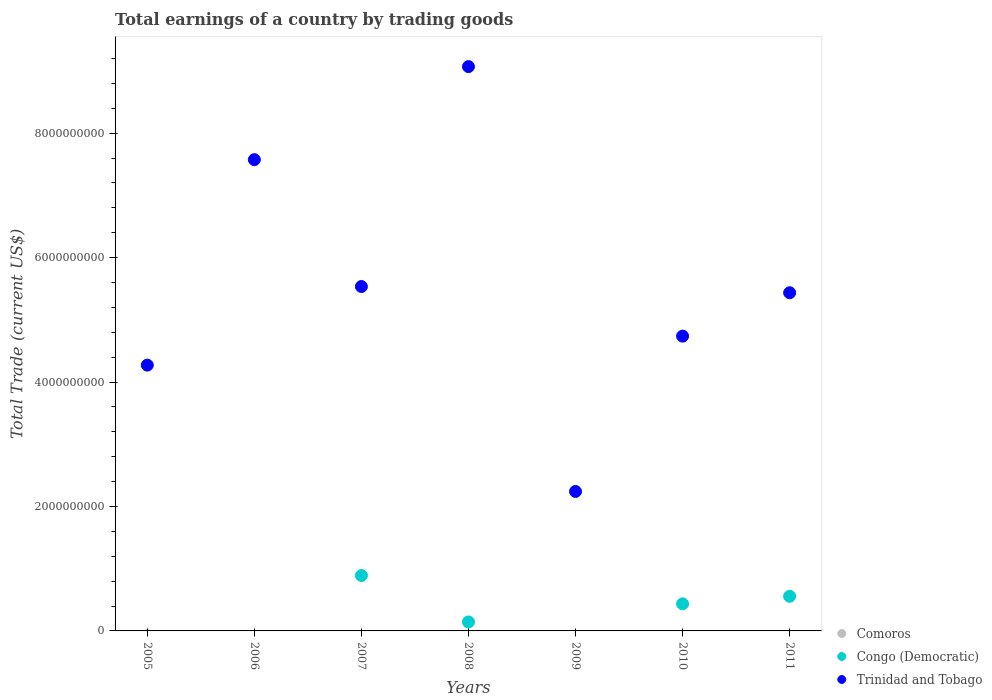Is the number of dotlines equal to the number of legend labels?
Your response must be concise. No. What is the total earnings in Comoros in 2011?
Provide a short and direct response. 0. Across all years, what is the maximum total earnings in Congo (Democratic)?
Offer a very short reply. 8.91e+08. Across all years, what is the minimum total earnings in Congo (Democratic)?
Provide a succinct answer. 0. In which year was the total earnings in Congo (Democratic) maximum?
Your answer should be compact. 2007. What is the total total earnings in Congo (Democratic) in the graph?
Your response must be concise. 2.03e+09. What is the difference between the total earnings in Trinidad and Tobago in 2005 and that in 2008?
Provide a short and direct response. -4.80e+09. What is the difference between the total earnings in Congo (Democratic) in 2006 and the total earnings in Trinidad and Tobago in 2010?
Keep it short and to the point. -4.74e+09. What is the average total earnings in Comoros per year?
Provide a succinct answer. 0. In the year 2008, what is the difference between the total earnings in Congo (Democratic) and total earnings in Trinidad and Tobago?
Your answer should be compact. -8.93e+09. In how many years, is the total earnings in Congo (Democratic) greater than 8400000000 US$?
Your answer should be compact. 0. What is the ratio of the total earnings in Congo (Democratic) in 2007 to that in 2008?
Provide a succinct answer. 6.19. Is the total earnings in Trinidad and Tobago in 2005 less than that in 2008?
Your answer should be compact. Yes. What is the difference between the highest and the second highest total earnings in Trinidad and Tobago?
Provide a succinct answer. 1.50e+09. What is the difference between the highest and the lowest total earnings in Congo (Democratic)?
Your answer should be compact. 8.91e+08. In how many years, is the total earnings in Comoros greater than the average total earnings in Comoros taken over all years?
Provide a succinct answer. 0. Is the sum of the total earnings in Trinidad and Tobago in 2009 and 2011 greater than the maximum total earnings in Comoros across all years?
Make the answer very short. Yes. Is it the case that in every year, the sum of the total earnings in Trinidad and Tobago and total earnings in Congo (Democratic)  is greater than the total earnings in Comoros?
Offer a very short reply. Yes. How many dotlines are there?
Offer a very short reply. 2. Does the graph contain any zero values?
Keep it short and to the point. Yes. Does the graph contain grids?
Provide a succinct answer. No. How are the legend labels stacked?
Offer a very short reply. Vertical. What is the title of the graph?
Offer a terse response. Total earnings of a country by trading goods. What is the label or title of the Y-axis?
Keep it short and to the point. Total Trade (current US$). What is the Total Trade (current US$) in Trinidad and Tobago in 2005?
Provide a succinct answer. 4.27e+09. What is the Total Trade (current US$) of Trinidad and Tobago in 2006?
Offer a terse response. 7.57e+09. What is the Total Trade (current US$) in Congo (Democratic) in 2007?
Offer a very short reply. 8.91e+08. What is the Total Trade (current US$) of Trinidad and Tobago in 2007?
Provide a short and direct response. 5.54e+09. What is the Total Trade (current US$) in Comoros in 2008?
Your answer should be compact. 0. What is the Total Trade (current US$) in Congo (Democratic) in 2008?
Provide a short and direct response. 1.44e+08. What is the Total Trade (current US$) in Trinidad and Tobago in 2008?
Provide a short and direct response. 9.07e+09. What is the Total Trade (current US$) in Comoros in 2009?
Your response must be concise. 0. What is the Total Trade (current US$) in Congo (Democratic) in 2009?
Your response must be concise. 0. What is the Total Trade (current US$) in Trinidad and Tobago in 2009?
Make the answer very short. 2.24e+09. What is the Total Trade (current US$) in Comoros in 2010?
Give a very brief answer. 0. What is the Total Trade (current US$) in Congo (Democratic) in 2010?
Keep it short and to the point. 4.35e+08. What is the Total Trade (current US$) of Trinidad and Tobago in 2010?
Your answer should be compact. 4.74e+09. What is the Total Trade (current US$) of Congo (Democratic) in 2011?
Make the answer very short. 5.56e+08. What is the Total Trade (current US$) of Trinidad and Tobago in 2011?
Make the answer very short. 5.43e+09. Across all years, what is the maximum Total Trade (current US$) of Congo (Democratic)?
Provide a succinct answer. 8.91e+08. Across all years, what is the maximum Total Trade (current US$) in Trinidad and Tobago?
Offer a very short reply. 9.07e+09. Across all years, what is the minimum Total Trade (current US$) of Trinidad and Tobago?
Offer a terse response. 2.24e+09. What is the total Total Trade (current US$) in Congo (Democratic) in the graph?
Give a very brief answer. 2.03e+09. What is the total Total Trade (current US$) of Trinidad and Tobago in the graph?
Provide a short and direct response. 3.89e+1. What is the difference between the Total Trade (current US$) of Trinidad and Tobago in 2005 and that in 2006?
Give a very brief answer. -3.30e+09. What is the difference between the Total Trade (current US$) in Trinidad and Tobago in 2005 and that in 2007?
Offer a terse response. -1.26e+09. What is the difference between the Total Trade (current US$) in Trinidad and Tobago in 2005 and that in 2008?
Your answer should be very brief. -4.80e+09. What is the difference between the Total Trade (current US$) of Trinidad and Tobago in 2005 and that in 2009?
Make the answer very short. 2.03e+09. What is the difference between the Total Trade (current US$) in Trinidad and Tobago in 2005 and that in 2010?
Provide a succinct answer. -4.66e+08. What is the difference between the Total Trade (current US$) of Trinidad and Tobago in 2005 and that in 2011?
Offer a very short reply. -1.16e+09. What is the difference between the Total Trade (current US$) in Trinidad and Tobago in 2006 and that in 2007?
Make the answer very short. 2.04e+09. What is the difference between the Total Trade (current US$) of Trinidad and Tobago in 2006 and that in 2008?
Your response must be concise. -1.50e+09. What is the difference between the Total Trade (current US$) of Trinidad and Tobago in 2006 and that in 2009?
Your answer should be compact. 5.33e+09. What is the difference between the Total Trade (current US$) in Trinidad and Tobago in 2006 and that in 2010?
Provide a short and direct response. 2.84e+09. What is the difference between the Total Trade (current US$) in Trinidad and Tobago in 2006 and that in 2011?
Offer a terse response. 2.14e+09. What is the difference between the Total Trade (current US$) in Congo (Democratic) in 2007 and that in 2008?
Your response must be concise. 7.47e+08. What is the difference between the Total Trade (current US$) in Trinidad and Tobago in 2007 and that in 2008?
Offer a terse response. -3.53e+09. What is the difference between the Total Trade (current US$) in Trinidad and Tobago in 2007 and that in 2009?
Give a very brief answer. 3.29e+09. What is the difference between the Total Trade (current US$) in Congo (Democratic) in 2007 and that in 2010?
Ensure brevity in your answer.  4.55e+08. What is the difference between the Total Trade (current US$) in Trinidad and Tobago in 2007 and that in 2010?
Give a very brief answer. 7.97e+08. What is the difference between the Total Trade (current US$) in Congo (Democratic) in 2007 and that in 2011?
Ensure brevity in your answer.  3.34e+08. What is the difference between the Total Trade (current US$) of Trinidad and Tobago in 2007 and that in 2011?
Keep it short and to the point. 1.01e+08. What is the difference between the Total Trade (current US$) of Trinidad and Tobago in 2008 and that in 2009?
Offer a terse response. 6.83e+09. What is the difference between the Total Trade (current US$) in Congo (Democratic) in 2008 and that in 2010?
Ensure brevity in your answer.  -2.91e+08. What is the difference between the Total Trade (current US$) in Trinidad and Tobago in 2008 and that in 2010?
Provide a short and direct response. 4.33e+09. What is the difference between the Total Trade (current US$) of Congo (Democratic) in 2008 and that in 2011?
Give a very brief answer. -4.12e+08. What is the difference between the Total Trade (current US$) in Trinidad and Tobago in 2008 and that in 2011?
Provide a short and direct response. 3.63e+09. What is the difference between the Total Trade (current US$) in Trinidad and Tobago in 2009 and that in 2010?
Ensure brevity in your answer.  -2.50e+09. What is the difference between the Total Trade (current US$) of Trinidad and Tobago in 2009 and that in 2011?
Provide a succinct answer. -3.19e+09. What is the difference between the Total Trade (current US$) in Congo (Democratic) in 2010 and that in 2011?
Provide a succinct answer. -1.21e+08. What is the difference between the Total Trade (current US$) of Trinidad and Tobago in 2010 and that in 2011?
Ensure brevity in your answer.  -6.97e+08. What is the difference between the Total Trade (current US$) of Congo (Democratic) in 2007 and the Total Trade (current US$) of Trinidad and Tobago in 2008?
Offer a very short reply. -8.18e+09. What is the difference between the Total Trade (current US$) in Congo (Democratic) in 2007 and the Total Trade (current US$) in Trinidad and Tobago in 2009?
Give a very brief answer. -1.35e+09. What is the difference between the Total Trade (current US$) of Congo (Democratic) in 2007 and the Total Trade (current US$) of Trinidad and Tobago in 2010?
Ensure brevity in your answer.  -3.85e+09. What is the difference between the Total Trade (current US$) of Congo (Democratic) in 2007 and the Total Trade (current US$) of Trinidad and Tobago in 2011?
Provide a succinct answer. -4.54e+09. What is the difference between the Total Trade (current US$) in Congo (Democratic) in 2008 and the Total Trade (current US$) in Trinidad and Tobago in 2009?
Offer a very short reply. -2.10e+09. What is the difference between the Total Trade (current US$) in Congo (Democratic) in 2008 and the Total Trade (current US$) in Trinidad and Tobago in 2010?
Ensure brevity in your answer.  -4.59e+09. What is the difference between the Total Trade (current US$) in Congo (Democratic) in 2008 and the Total Trade (current US$) in Trinidad and Tobago in 2011?
Offer a terse response. -5.29e+09. What is the difference between the Total Trade (current US$) of Congo (Democratic) in 2010 and the Total Trade (current US$) of Trinidad and Tobago in 2011?
Make the answer very short. -5.00e+09. What is the average Total Trade (current US$) of Comoros per year?
Offer a very short reply. 0. What is the average Total Trade (current US$) in Congo (Democratic) per year?
Provide a succinct answer. 2.89e+08. What is the average Total Trade (current US$) of Trinidad and Tobago per year?
Provide a short and direct response. 5.55e+09. In the year 2007, what is the difference between the Total Trade (current US$) in Congo (Democratic) and Total Trade (current US$) in Trinidad and Tobago?
Keep it short and to the point. -4.64e+09. In the year 2008, what is the difference between the Total Trade (current US$) in Congo (Democratic) and Total Trade (current US$) in Trinidad and Tobago?
Your answer should be compact. -8.93e+09. In the year 2010, what is the difference between the Total Trade (current US$) of Congo (Democratic) and Total Trade (current US$) of Trinidad and Tobago?
Provide a short and direct response. -4.30e+09. In the year 2011, what is the difference between the Total Trade (current US$) of Congo (Democratic) and Total Trade (current US$) of Trinidad and Tobago?
Keep it short and to the point. -4.88e+09. What is the ratio of the Total Trade (current US$) in Trinidad and Tobago in 2005 to that in 2006?
Offer a very short reply. 0.56. What is the ratio of the Total Trade (current US$) of Trinidad and Tobago in 2005 to that in 2007?
Offer a terse response. 0.77. What is the ratio of the Total Trade (current US$) of Trinidad and Tobago in 2005 to that in 2008?
Offer a terse response. 0.47. What is the ratio of the Total Trade (current US$) of Trinidad and Tobago in 2005 to that in 2009?
Your response must be concise. 1.91. What is the ratio of the Total Trade (current US$) of Trinidad and Tobago in 2005 to that in 2010?
Your answer should be compact. 0.9. What is the ratio of the Total Trade (current US$) of Trinidad and Tobago in 2005 to that in 2011?
Give a very brief answer. 0.79. What is the ratio of the Total Trade (current US$) in Trinidad and Tobago in 2006 to that in 2007?
Your response must be concise. 1.37. What is the ratio of the Total Trade (current US$) of Trinidad and Tobago in 2006 to that in 2008?
Your answer should be very brief. 0.84. What is the ratio of the Total Trade (current US$) of Trinidad and Tobago in 2006 to that in 2009?
Offer a terse response. 3.38. What is the ratio of the Total Trade (current US$) of Trinidad and Tobago in 2006 to that in 2010?
Offer a terse response. 1.6. What is the ratio of the Total Trade (current US$) of Trinidad and Tobago in 2006 to that in 2011?
Provide a short and direct response. 1.39. What is the ratio of the Total Trade (current US$) in Congo (Democratic) in 2007 to that in 2008?
Your answer should be very brief. 6.19. What is the ratio of the Total Trade (current US$) of Trinidad and Tobago in 2007 to that in 2008?
Your response must be concise. 0.61. What is the ratio of the Total Trade (current US$) of Trinidad and Tobago in 2007 to that in 2009?
Your answer should be very brief. 2.47. What is the ratio of the Total Trade (current US$) in Congo (Democratic) in 2007 to that in 2010?
Provide a short and direct response. 2.05. What is the ratio of the Total Trade (current US$) in Trinidad and Tobago in 2007 to that in 2010?
Your response must be concise. 1.17. What is the ratio of the Total Trade (current US$) of Congo (Democratic) in 2007 to that in 2011?
Provide a short and direct response. 1.6. What is the ratio of the Total Trade (current US$) in Trinidad and Tobago in 2007 to that in 2011?
Provide a succinct answer. 1.02. What is the ratio of the Total Trade (current US$) of Trinidad and Tobago in 2008 to that in 2009?
Your answer should be very brief. 4.05. What is the ratio of the Total Trade (current US$) in Congo (Democratic) in 2008 to that in 2010?
Make the answer very short. 0.33. What is the ratio of the Total Trade (current US$) in Trinidad and Tobago in 2008 to that in 2010?
Provide a short and direct response. 1.91. What is the ratio of the Total Trade (current US$) in Congo (Democratic) in 2008 to that in 2011?
Your response must be concise. 0.26. What is the ratio of the Total Trade (current US$) in Trinidad and Tobago in 2008 to that in 2011?
Keep it short and to the point. 1.67. What is the ratio of the Total Trade (current US$) in Trinidad and Tobago in 2009 to that in 2010?
Your response must be concise. 0.47. What is the ratio of the Total Trade (current US$) of Trinidad and Tobago in 2009 to that in 2011?
Offer a very short reply. 0.41. What is the ratio of the Total Trade (current US$) of Congo (Democratic) in 2010 to that in 2011?
Provide a short and direct response. 0.78. What is the ratio of the Total Trade (current US$) of Trinidad and Tobago in 2010 to that in 2011?
Ensure brevity in your answer.  0.87. What is the difference between the highest and the second highest Total Trade (current US$) of Congo (Democratic)?
Your answer should be compact. 3.34e+08. What is the difference between the highest and the second highest Total Trade (current US$) of Trinidad and Tobago?
Your answer should be compact. 1.50e+09. What is the difference between the highest and the lowest Total Trade (current US$) of Congo (Democratic)?
Your answer should be very brief. 8.91e+08. What is the difference between the highest and the lowest Total Trade (current US$) in Trinidad and Tobago?
Provide a succinct answer. 6.83e+09. 